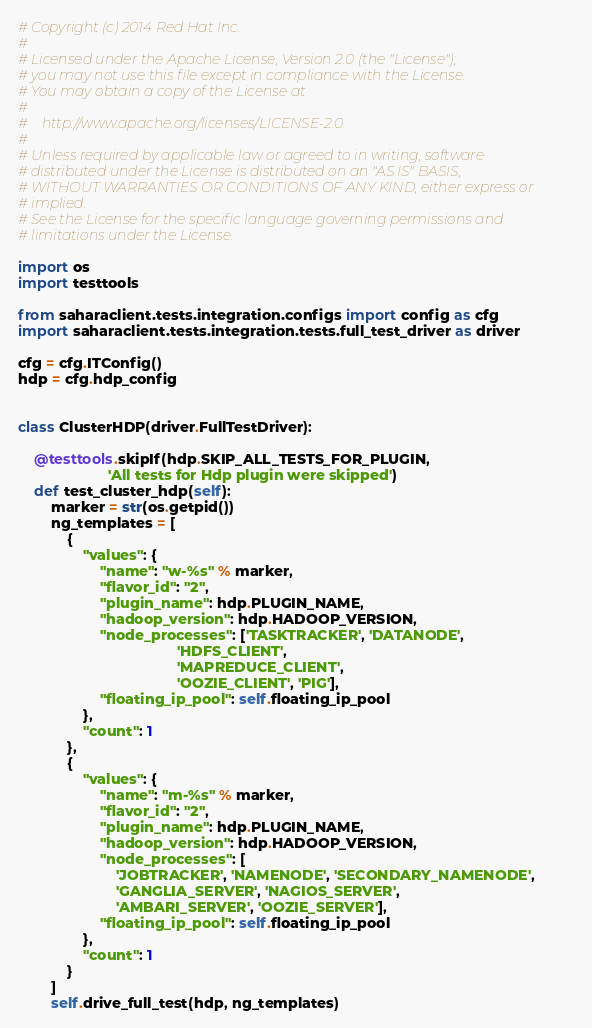<code> <loc_0><loc_0><loc_500><loc_500><_Python_># Copyright (c) 2014 Red Hat Inc.
#
# Licensed under the Apache License, Version 2.0 (the "License");
# you may not use this file except in compliance with the License.
# You may obtain a copy of the License at
#
#    http://www.apache.org/licenses/LICENSE-2.0
#
# Unless required by applicable law or agreed to in writing, software
# distributed under the License is distributed on an "AS IS" BASIS,
# WITHOUT WARRANTIES OR CONDITIONS OF ANY KIND, either express or
# implied.
# See the License for the specific language governing permissions and
# limitations under the License.

import os
import testtools

from saharaclient.tests.integration.configs import config as cfg
import saharaclient.tests.integration.tests.full_test_driver as driver

cfg = cfg.ITConfig()
hdp = cfg.hdp_config


class ClusterHDP(driver.FullTestDriver):

    @testtools.skipIf(hdp.SKIP_ALL_TESTS_FOR_PLUGIN,
                      'All tests for Hdp plugin were skipped')
    def test_cluster_hdp(self):
        marker = str(os.getpid())
        ng_templates = [
            {
                "values": {
                    "name": "w-%s" % marker,
                    "flavor_id": "2",
                    "plugin_name": hdp.PLUGIN_NAME,
                    "hadoop_version": hdp.HADOOP_VERSION,
                    "node_processes": ['TASKTRACKER', 'DATANODE',
                                       'HDFS_CLIENT',
                                       'MAPREDUCE_CLIENT',
                                       'OOZIE_CLIENT', 'PIG'],
                    "floating_ip_pool": self.floating_ip_pool
                },
                "count": 1
            },
            {
                "values": {
                    "name": "m-%s" % marker,
                    "flavor_id": "2",
                    "plugin_name": hdp.PLUGIN_NAME,
                    "hadoop_version": hdp.HADOOP_VERSION,
                    "node_processes": [
                        'JOBTRACKER', 'NAMENODE', 'SECONDARY_NAMENODE',
                        'GANGLIA_SERVER', 'NAGIOS_SERVER',
                        'AMBARI_SERVER', 'OOZIE_SERVER'],
                    "floating_ip_pool": self.floating_ip_pool
                },
                "count": 1
            }
        ]
        self.drive_full_test(hdp, ng_templates)
</code> 